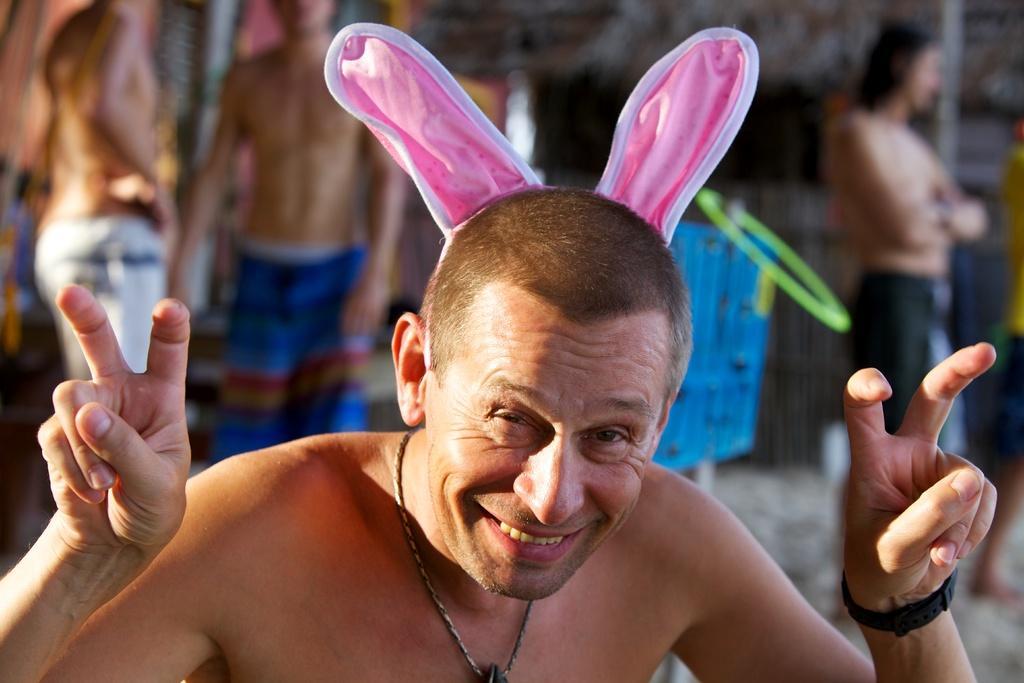Please provide a concise description of this image. A man is showing his fingers, he wore pink color cloth on his head. 